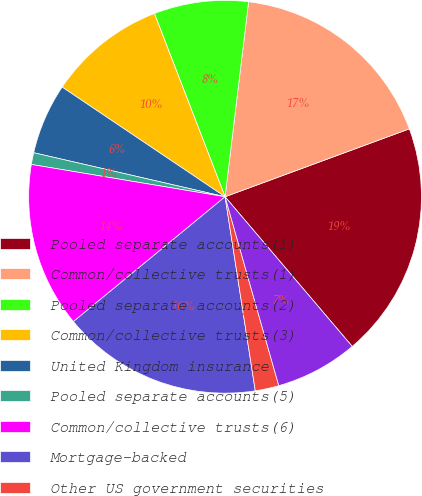Convert chart to OTSL. <chart><loc_0><loc_0><loc_500><loc_500><pie_chart><fcel>Pooled separate accounts(1)<fcel>Common/collective trusts(1)<fcel>Pooled separate accounts(2)<fcel>Common/collective trusts(3)<fcel>United Kingdom insurance<fcel>Pooled separate accounts(5)<fcel>Common/collective trusts(6)<fcel>Mortgage-backed<fcel>Other US government securities<fcel>US government securities<nl><fcel>19.41%<fcel>17.47%<fcel>7.77%<fcel>9.71%<fcel>5.83%<fcel>0.97%<fcel>13.59%<fcel>16.5%<fcel>1.95%<fcel>6.8%<nl></chart> 